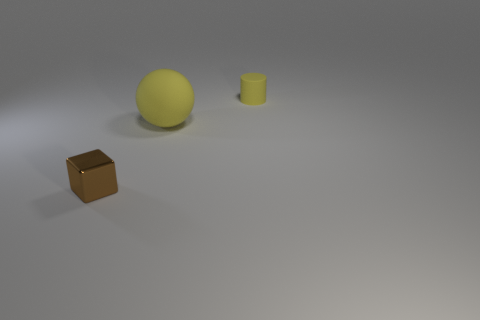Add 2 brown metal objects. How many objects exist? 5 Subtract all blocks. How many objects are left? 2 Add 1 brown cubes. How many brown cubes exist? 2 Subtract 0 green balls. How many objects are left? 3 Subtract all small brown objects. Subtract all cylinders. How many objects are left? 1 Add 1 yellow balls. How many yellow balls are left? 2 